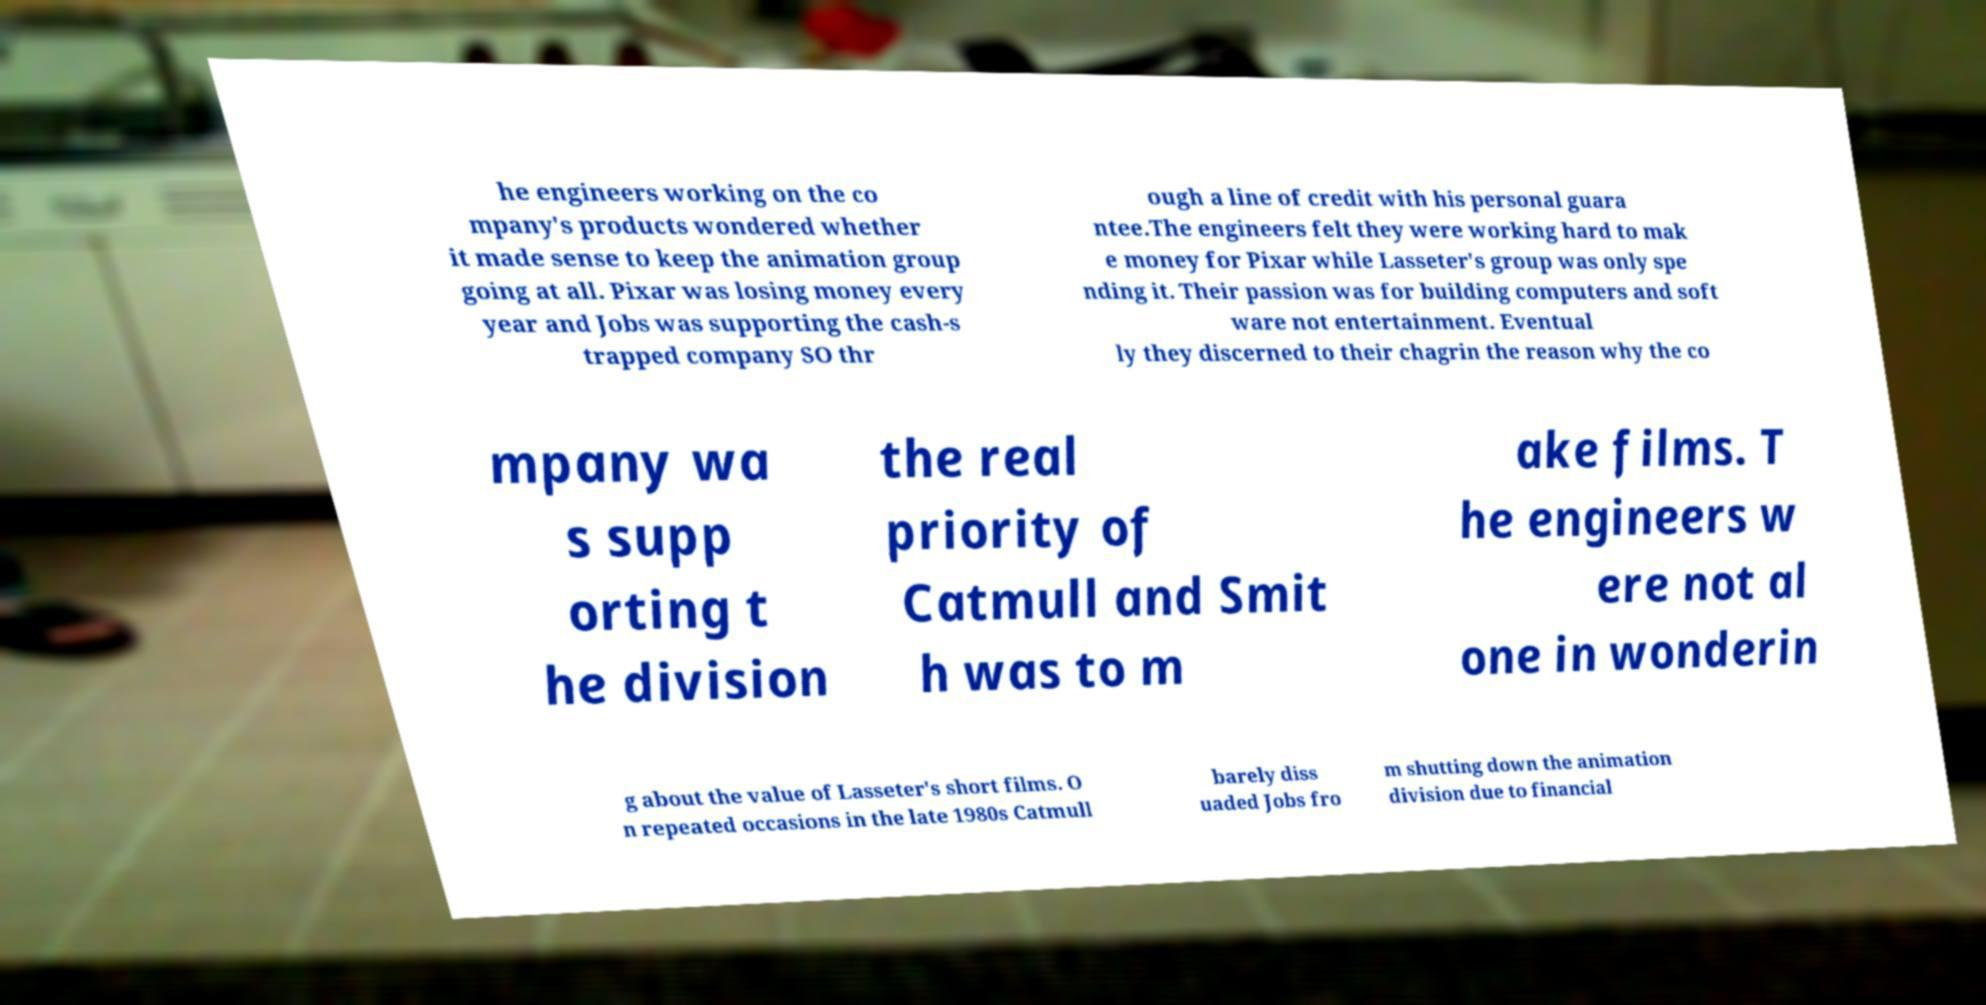Could you extract and type out the text from this image? he engineers working on the co mpany's products wondered whether it made sense to keep the animation group going at all. Pixar was losing money every year and Jobs was supporting the cash-s trapped company SO thr ough a line of credit with his personal guara ntee.The engineers felt they were working hard to mak e money for Pixar while Lasseter's group was only spe nding it. Their passion was for building computers and soft ware not entertainment. Eventual ly they discerned to their chagrin the reason why the co mpany wa s supp orting t he division the real priority of Catmull and Smit h was to m ake films. T he engineers w ere not al one in wonderin g about the value of Lasseter's short films. O n repeated occasions in the late 1980s Catmull barely diss uaded Jobs fro m shutting down the animation division due to financial 